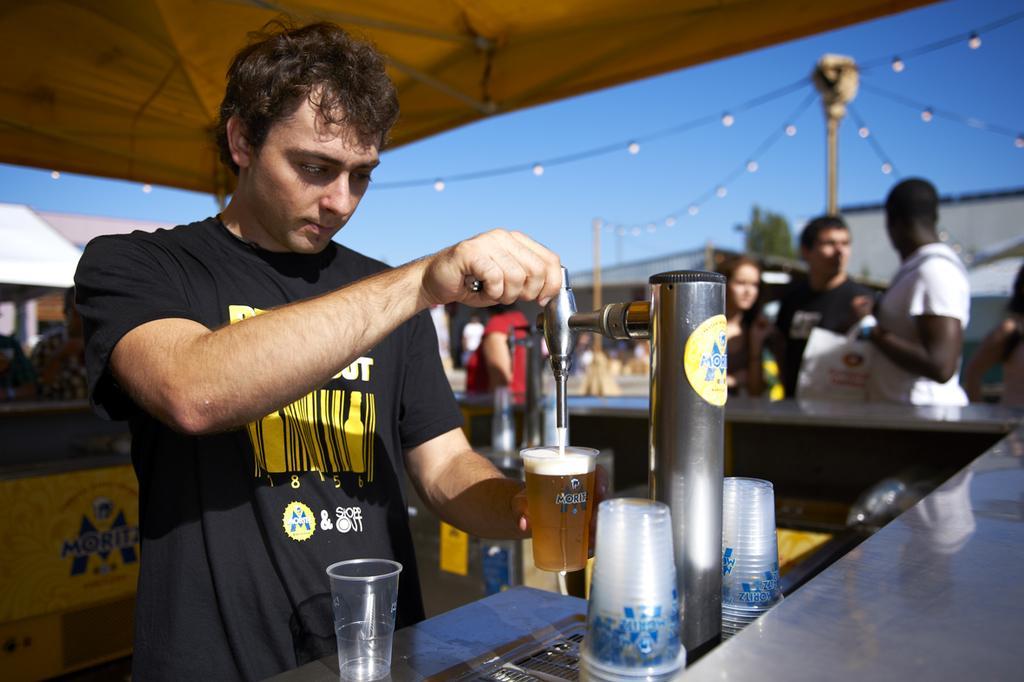How would you summarize this image in a sentence or two? this picture is taken at stalls. It's a sunny day. The man in the front is wearing a black T-shirt and there is some text on it. He is filling a glass with drink from the machine, In front of him there is desk and glasses are placed on it. In the right corner of the image there are four people standing and one among them is holding a bag. In the background there is crowd, some stalls, building, a pillar and fairy lights hanged on it.  